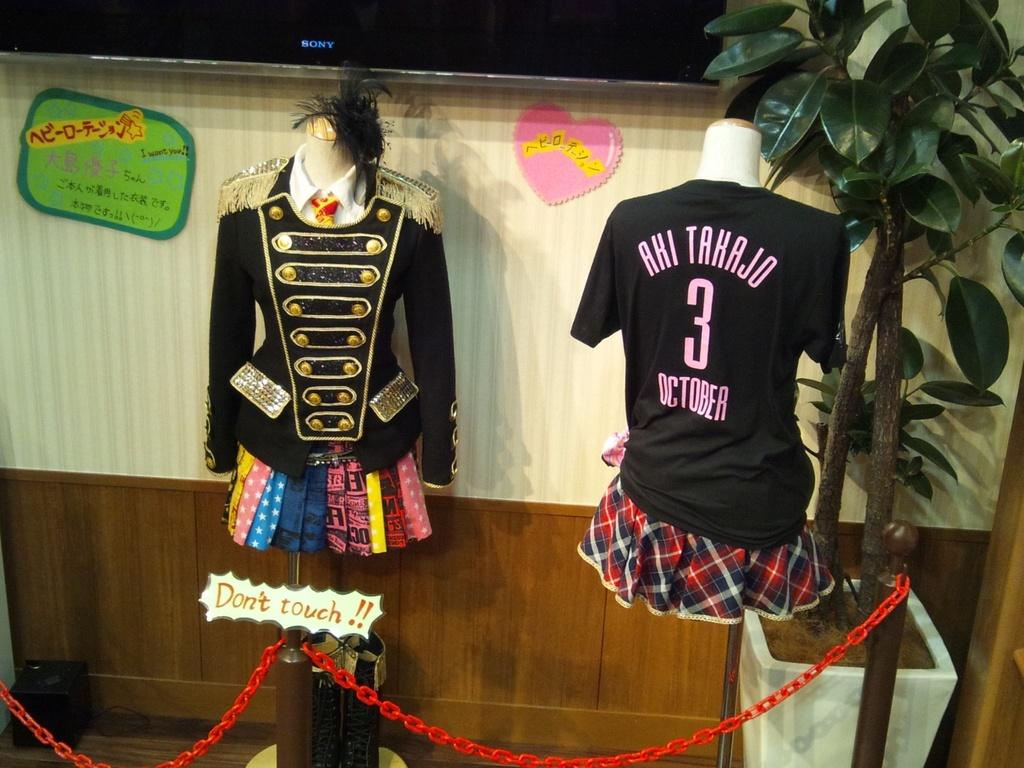<image>
Give a short and clear explanation of the subsequent image. Aki Tahajo October shirt with number 3 on the back in the middle. 